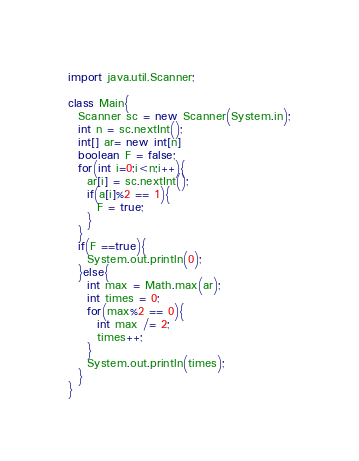<code> <loc_0><loc_0><loc_500><loc_500><_Java_>import java.util.Scanner;

class Main{
  Scanner sc = new Scanner(System.in);
  int n = sc.nextInt();
  int[] ar= new int[n]
  boolean F = false;  
  for(int i=0;i<n;i++){
    ar[i] = sc.nextInt();
    if(a[i]%2 == 1){
      F = true;
    }  
  }
  if(F ==true){
    System.out.println(0);
  }else{
    int max = Math.max(ar);
    int times = 0;
    for(max%2 == 0){
      int max /= 2;
      times++;
    }
    System.out.println(times);
  }  
}  </code> 